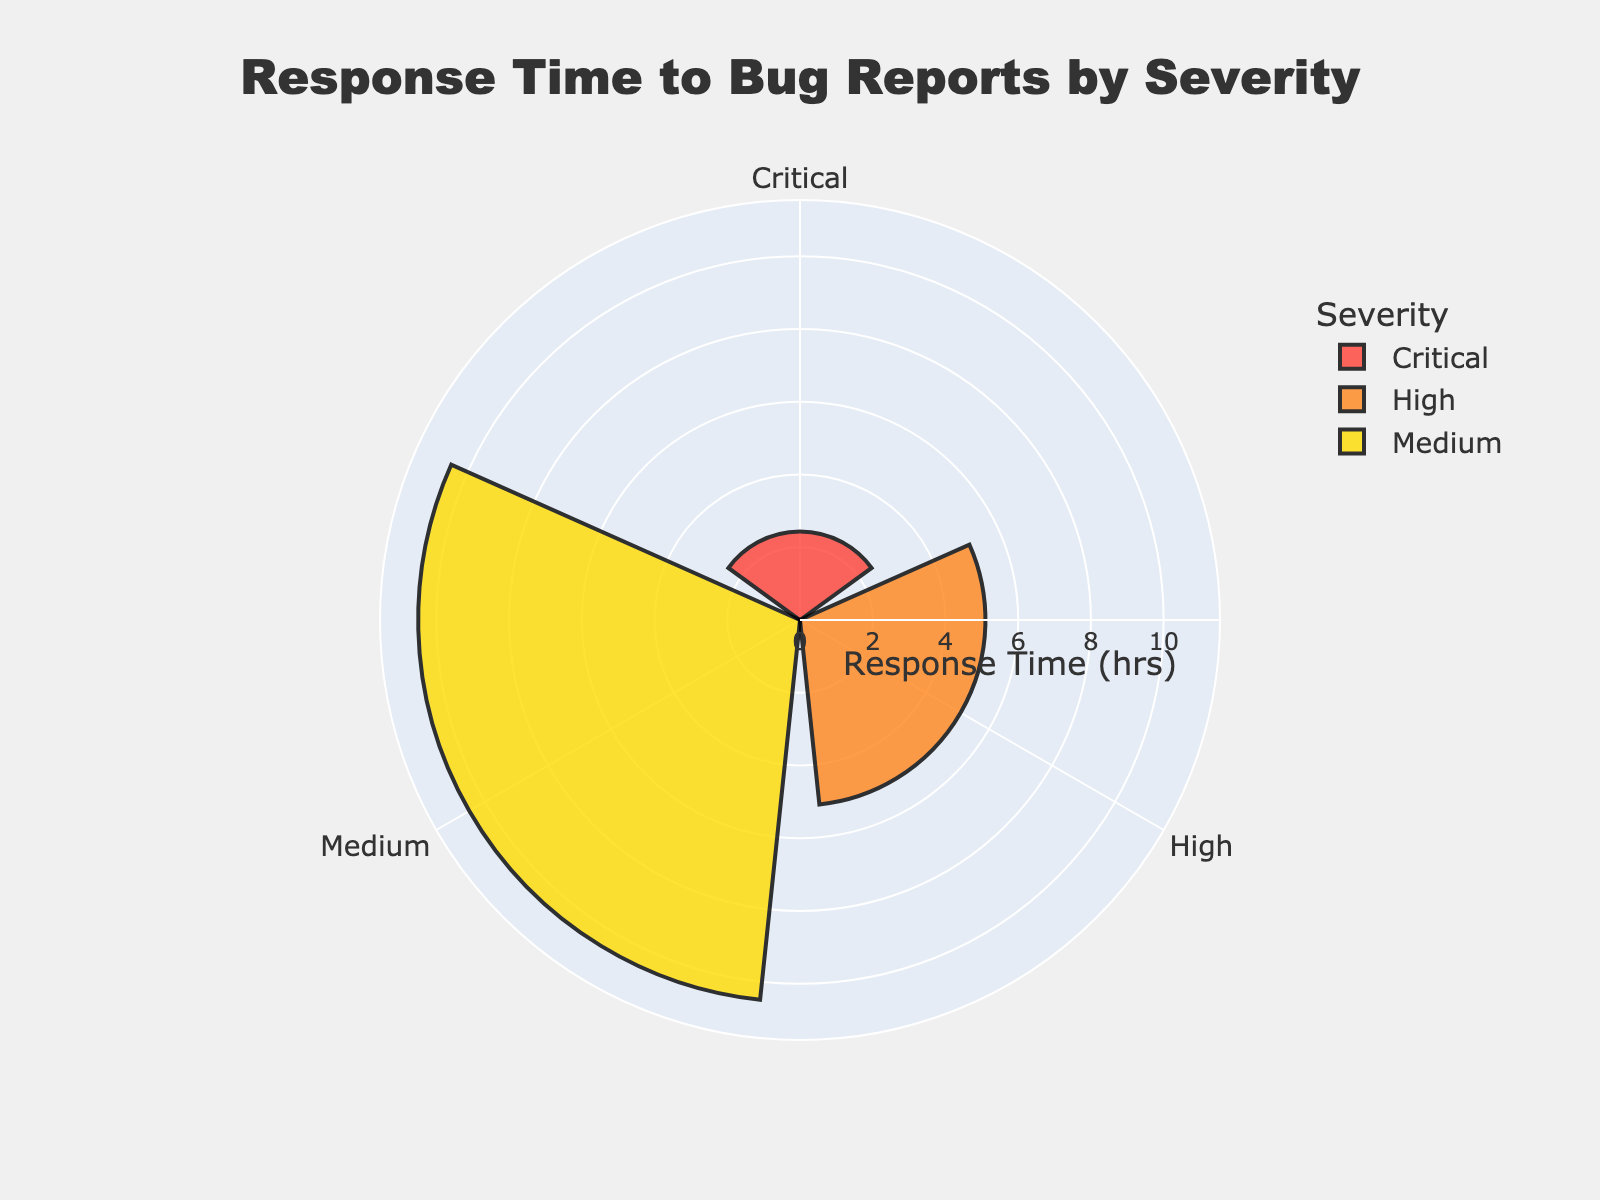What's the title of the figure? The title is displayed prominently at the top of the figure, usually indicating what the graph represents.
Answer: Response Time to Bug Reports by Severity What are the severity levels reported in the figure? By observing the angles or sectors on the rose chart, each named group corresponds to a severity level.
Answer: Critical, High, Medium Which severity level has the highest average response time? By comparing the radial extent of each bar corresponding to severity levels, we can identify the one with the greatest length.
Answer: Medium What's the average response time for Critical severity bug reports? We observe the radial length of the bar associated with the 'Critical' severity.
Answer: 2.43 hours How does the average response time for High severity compare to Critical severity? By comparing the radial lengths of the bars for 'High' and 'Critical' severities, we can see which one is longer or shorter.
Answer: High is greater than Critical What is the range of the radial axis in the chart? By examining the radial axis settings indicated on the plot, we can determine its minimum and maximum values.
Answer: 0 to around 12.4 hours Is the response time for Critical severity less than for Medium severity? By comparing the radial lengths of bars for 'Critical' and 'Medium' severities, we can see whether the 'Critical' bar is shorter.
Answer: Yes What's the difference in average response time between High and Medium severities? Subtract the average response time of the 'High' severity bar from that of the 'Medium' severity bar.
Answer: Approximately 5.8 hours Which color is used for the Critical severity level? By observing the color legend associated with the bars on the chart, we identify the color used for 'Critical'.
Answer: Red How many severity levels are represented in the chart? By counting the discrete labels or segments on the rose chart, we determine the total number of severity levels.
Answer: 3 